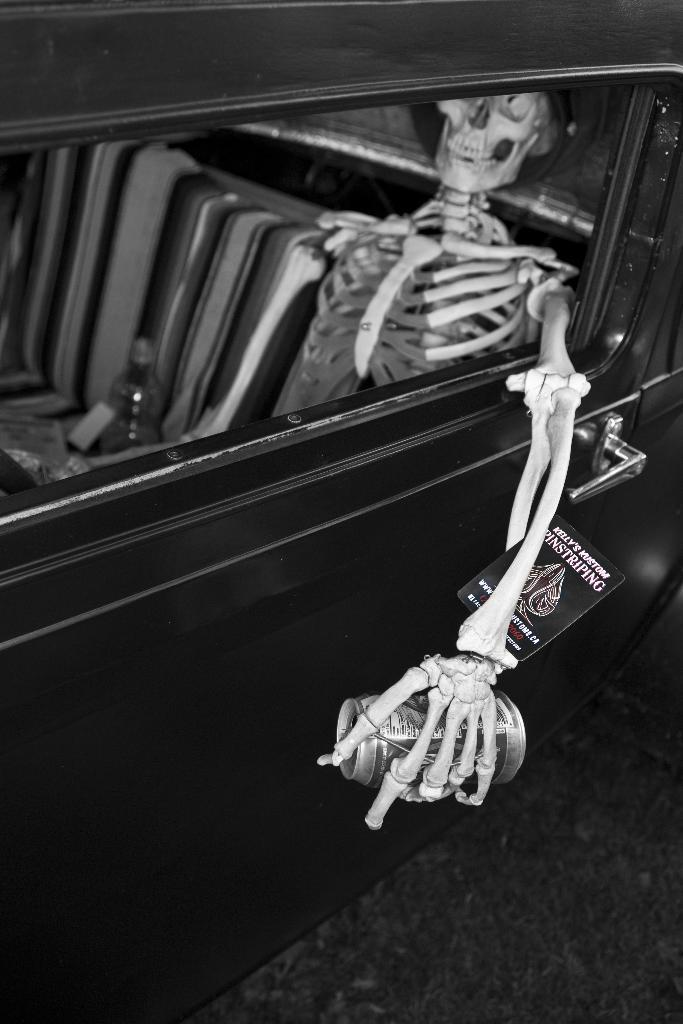Can you describe this image briefly? This is a black and white image and here we can see a car and inside the car, there is a bottle and a skeleton which is holding a tin and there is a tag. At the bottom, there is a road. 